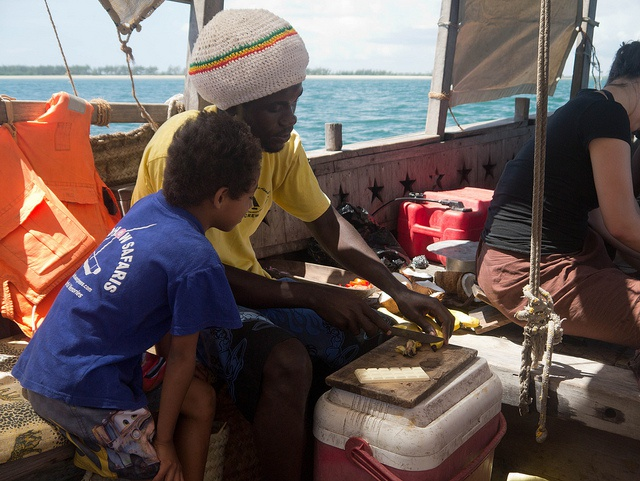Describe the objects in this image and their specific colors. I can see people in lightgray, black, navy, blue, and maroon tones, people in lightgray, black, darkgray, and olive tones, people in lightgray, black, brown, and maroon tones, boat in lightgray, gray, maroon, and black tones, and knife in black, gray, and lavender tones in this image. 